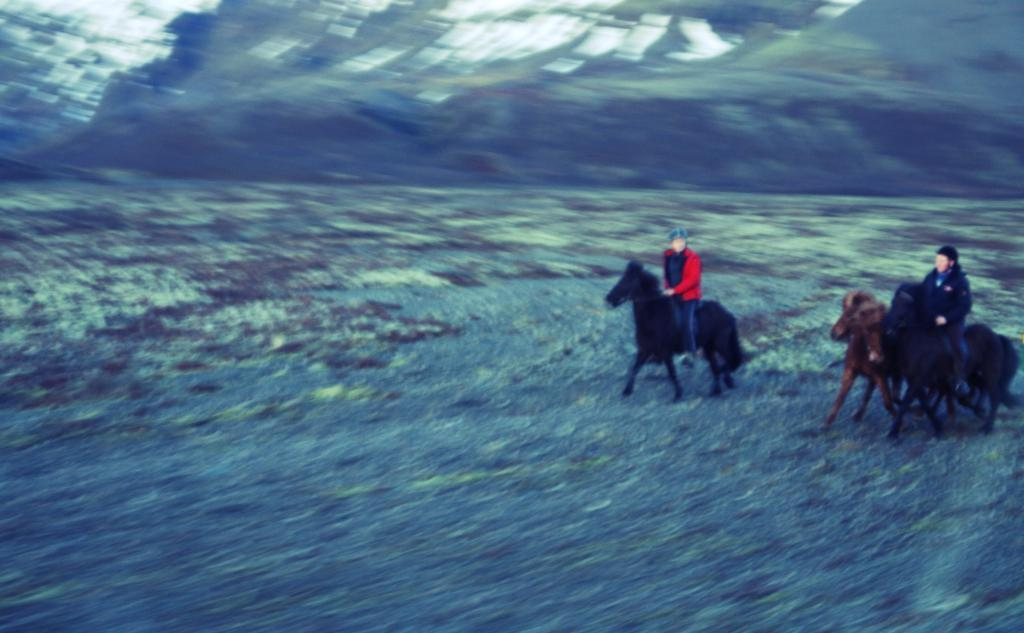What animals are present in the image? There are horses in the image. What are the horses doing in the image? At least two persons are riding horses in the image, although the exact number may be uncertain due to the blurry image. What type of thread is being used to sew the process in the image? There is no process or thread present in the image; it features horses and riders. 